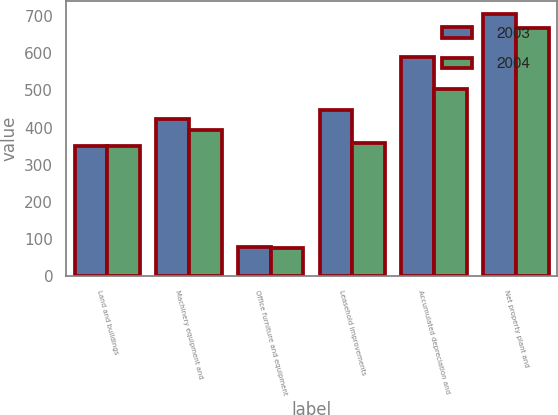Convert chart. <chart><loc_0><loc_0><loc_500><loc_500><stacked_bar_chart><ecel><fcel>Land and buildings<fcel>Machinery equipment and<fcel>Office furniture and equipment<fcel>Leasehold improvements<fcel>Accumulated depreciation and<fcel>Net property plant and<nl><fcel>2003<fcel>351<fcel>422<fcel>79<fcel>446<fcel>591<fcel>707<nl><fcel>2004<fcel>350<fcel>393<fcel>74<fcel>357<fcel>505<fcel>669<nl></chart> 